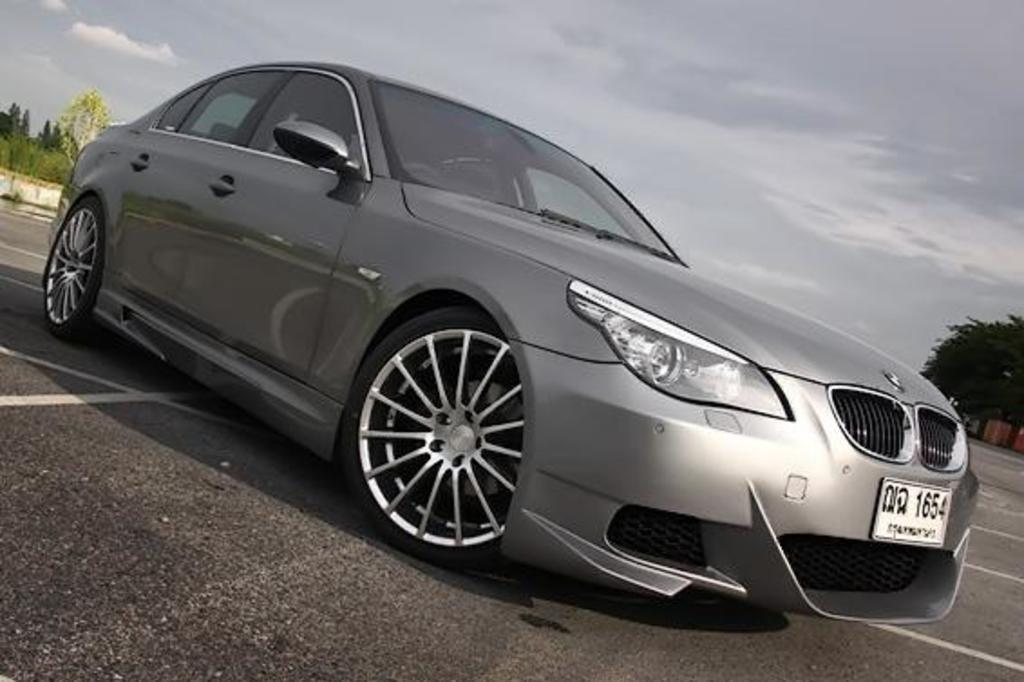What type of vehicle is in the image? There is a silver car in the image. Where is the car located in the image? The car is parked on the road. What can be seen in the background behind the car? There are trees visible behind the car. How many crows are sitting on the car in the image? There are no crows present on the car in the image. What type of muscle is visible on the car in the image? Cars do not have muscles; they have engines and other mechanical components. 